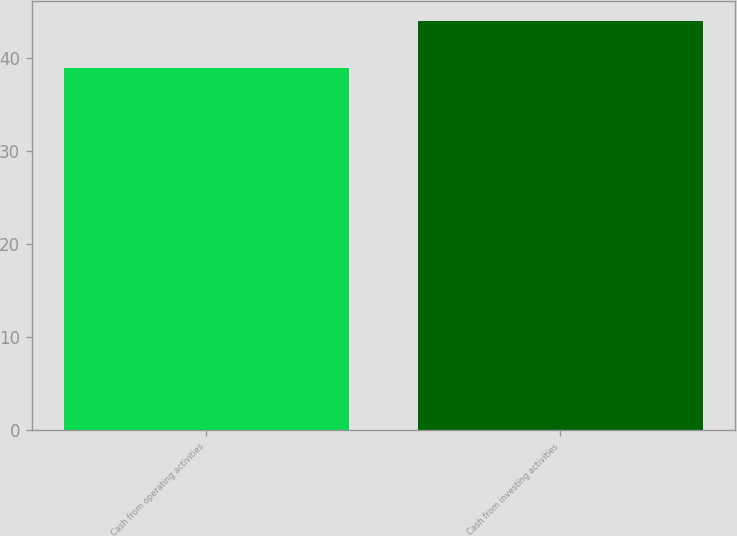Convert chart to OTSL. <chart><loc_0><loc_0><loc_500><loc_500><bar_chart><fcel>Cash from operating activities<fcel>Cash from investing activities<nl><fcel>39<fcel>44<nl></chart> 